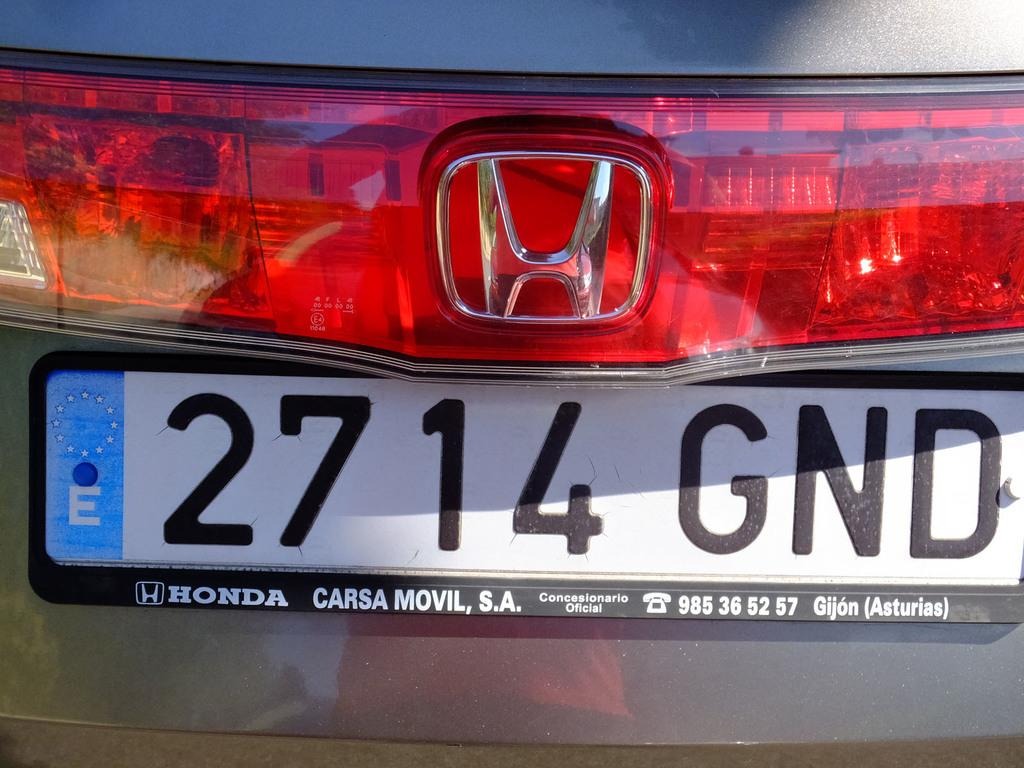<image>
Write a terse but informative summary of the picture. Car with a license plate that says 2714 GND on the back. 